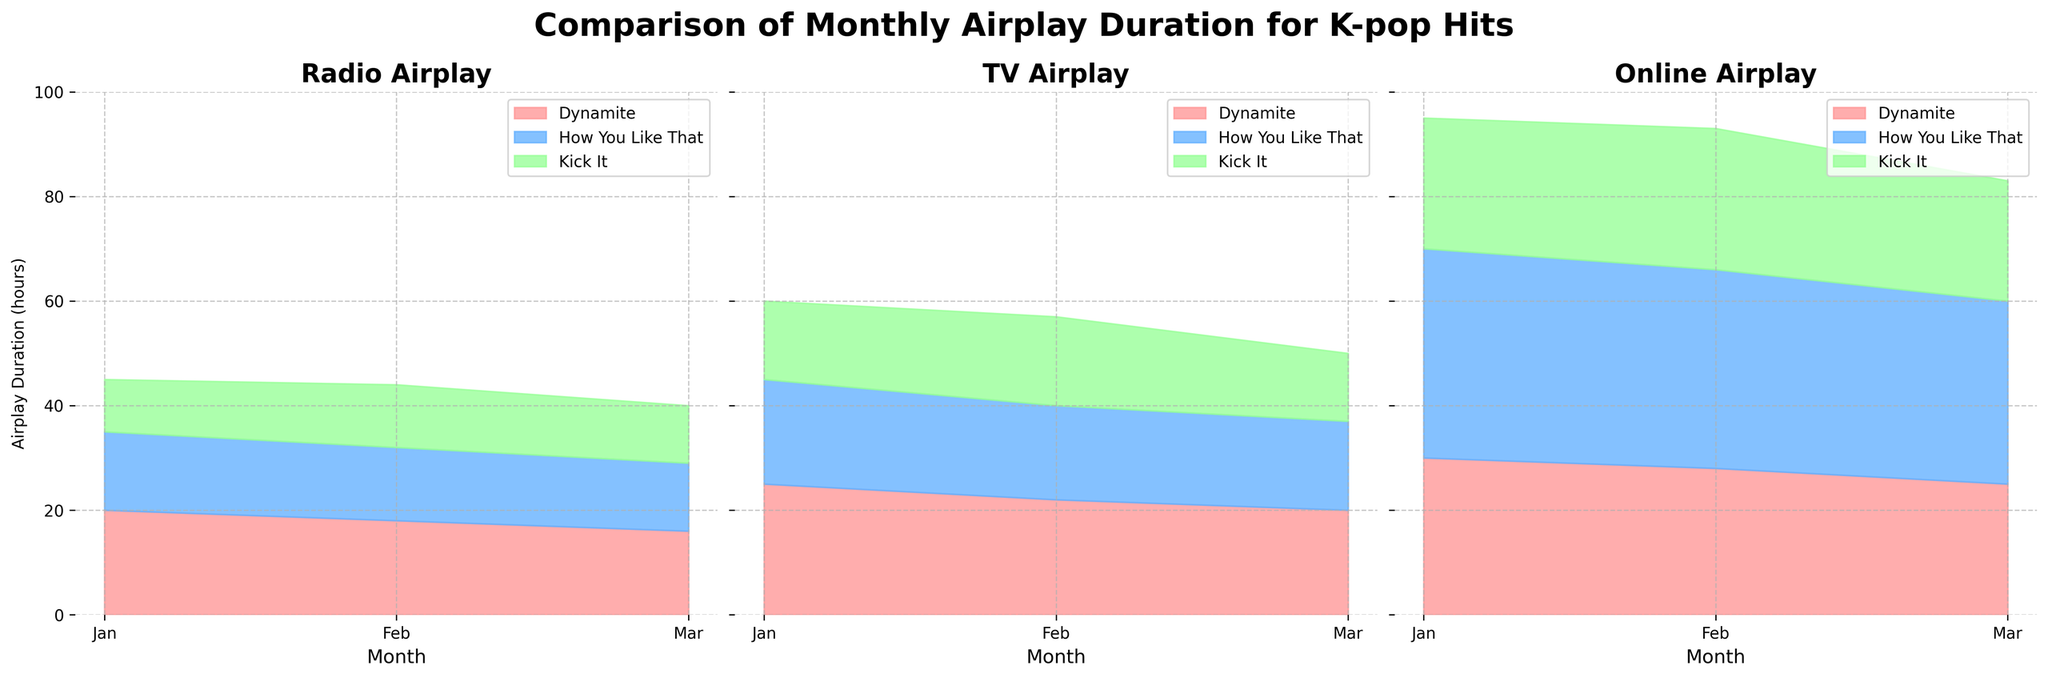What songs are compared in the figure? The figure compares three songs: BTS's "Dynamite," BLACKPINK's "How You Like That," and NCT 127's "Kick It."
Answer: BTS - Dynamite, BLACKPINK - How You Like That, NCT 127 - Kick It Which song has the highest airplay duration on Online channels in January? Based on the figure, "BLACKPINK - How You Like That" has the highest airplay duration among the songs in Online channels for January.
Answer: BLACKPINK - How You Like That Is there a month where the total airplay duration for "NCT 127 - Kick It" is the same across all three channels? No, the airplay durations for "NCT 127 - Kick It" vary each month across Radio, TV, and Online channels in the figure.
Answer: No Which channel shows the most significant decrease in airplay duration for BTS's "Dynamite" from January to March? By comparing the areas in the Radio, TV, and Online subplots, the Radio channel shows the most significant decrease in airplay duration for BTS's "Dynamite" from January to March.
Answer: Radio What is the combined airplay duration of "BLACKPINK - How You Like That" on TV across January and February? The airplay duration on TV for "BLACKPINK - How You Like That" in January is 20 hours, and in February, it is 18 hours. Summing these up gives 20 + 18 = 38 hours.
Answer: 38 hours Which channel has the highest overall airplay duration in January? By observing the Y-axis values of the filled areas for January, the Online channel has the highest overall airplay duration in January compared to Radio and TV.
Answer: Online What is the difference in airplay duration for "NCT 127 - Kick It" between TV and Online channels in March? The TV airplay duration for "NCT 127 - Kick It" in March is 13 hours, and Online is 23 hours. The difference is 23 - 13 = 10 hours.
Answer: 10 hours Which song shows the most consistent airplay duration across all three channels over the three months? By examining the areas for each song across Radio, TV, and Online channels, "BTS - Dynamite" appears to have the most consistent and balanced airplay duration over the three months.
Answer: BTS - Dynamite 